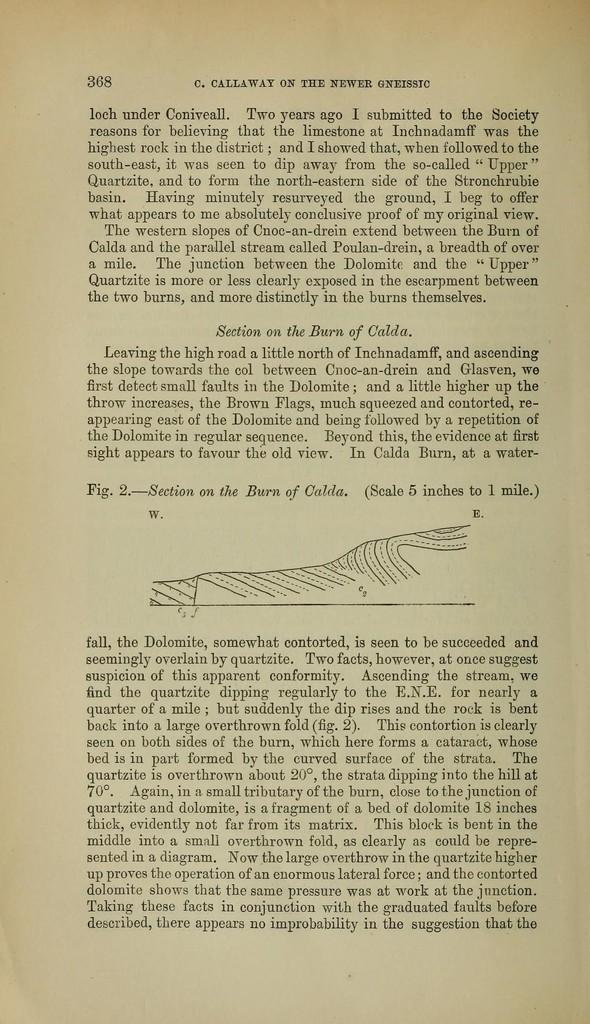Provide a one-sentence caption for the provided image. Page 368 of the book C. Callaway on the newer gneissic. 